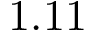Convert formula to latex. <formula><loc_0><loc_0><loc_500><loc_500>1 . 1 1</formula> 